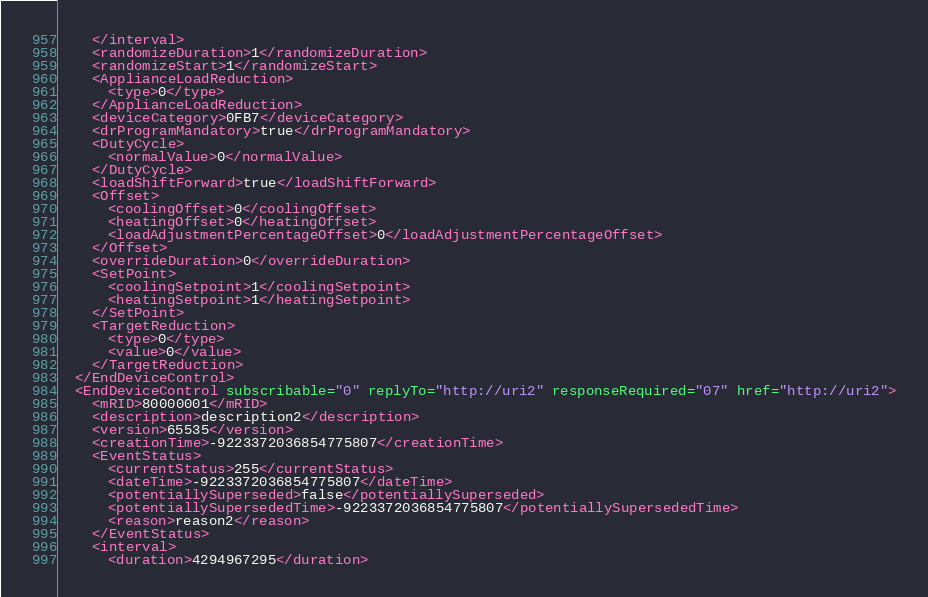<code> <loc_0><loc_0><loc_500><loc_500><_XML_>    </interval>
    <randomizeDuration>1</randomizeDuration>
    <randomizeStart>1</randomizeStart>
    <ApplianceLoadReduction>
      <type>0</type>
    </ApplianceLoadReduction>
    <deviceCategory>0FB7</deviceCategory>
    <drProgramMandatory>true</drProgramMandatory>
    <DutyCycle>
      <normalValue>0</normalValue>
    </DutyCycle>
    <loadShiftForward>true</loadShiftForward>
    <Offset>
      <coolingOffset>0</coolingOffset>
      <heatingOffset>0</heatingOffset>
      <loadAdjustmentPercentageOffset>0</loadAdjustmentPercentageOffset>
    </Offset>
    <overrideDuration>0</overrideDuration>
    <SetPoint>
      <coolingSetpoint>1</coolingSetpoint>
      <heatingSetpoint>1</heatingSetpoint>
    </SetPoint>
    <TargetReduction>
      <type>0</type>
      <value>0</value>
    </TargetReduction>
  </EndDeviceControl>
  <EndDeviceControl subscribable="0" replyTo="http://uri2" responseRequired="07" href="http://uri2">
    <mRID>80000001</mRID>
    <description>description2</description>
    <version>65535</version>
    <creationTime>-9223372036854775807</creationTime>
    <EventStatus>
      <currentStatus>255</currentStatus>
      <dateTime>-9223372036854775807</dateTime>
      <potentiallySuperseded>false</potentiallySuperseded>
      <potentiallySupersededTime>-9223372036854775807</potentiallySupersededTime>
      <reason>reason2</reason>
    </EventStatus>
    <interval>
      <duration>4294967295</duration></code> 